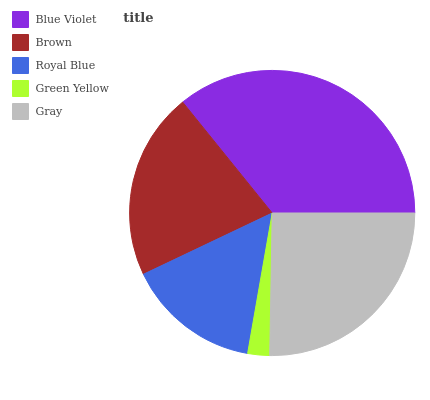Is Green Yellow the minimum?
Answer yes or no. Yes. Is Blue Violet the maximum?
Answer yes or no. Yes. Is Brown the minimum?
Answer yes or no. No. Is Brown the maximum?
Answer yes or no. No. Is Blue Violet greater than Brown?
Answer yes or no. Yes. Is Brown less than Blue Violet?
Answer yes or no. Yes. Is Brown greater than Blue Violet?
Answer yes or no. No. Is Blue Violet less than Brown?
Answer yes or no. No. Is Brown the high median?
Answer yes or no. Yes. Is Brown the low median?
Answer yes or no. Yes. Is Gray the high median?
Answer yes or no. No. Is Green Yellow the low median?
Answer yes or no. No. 